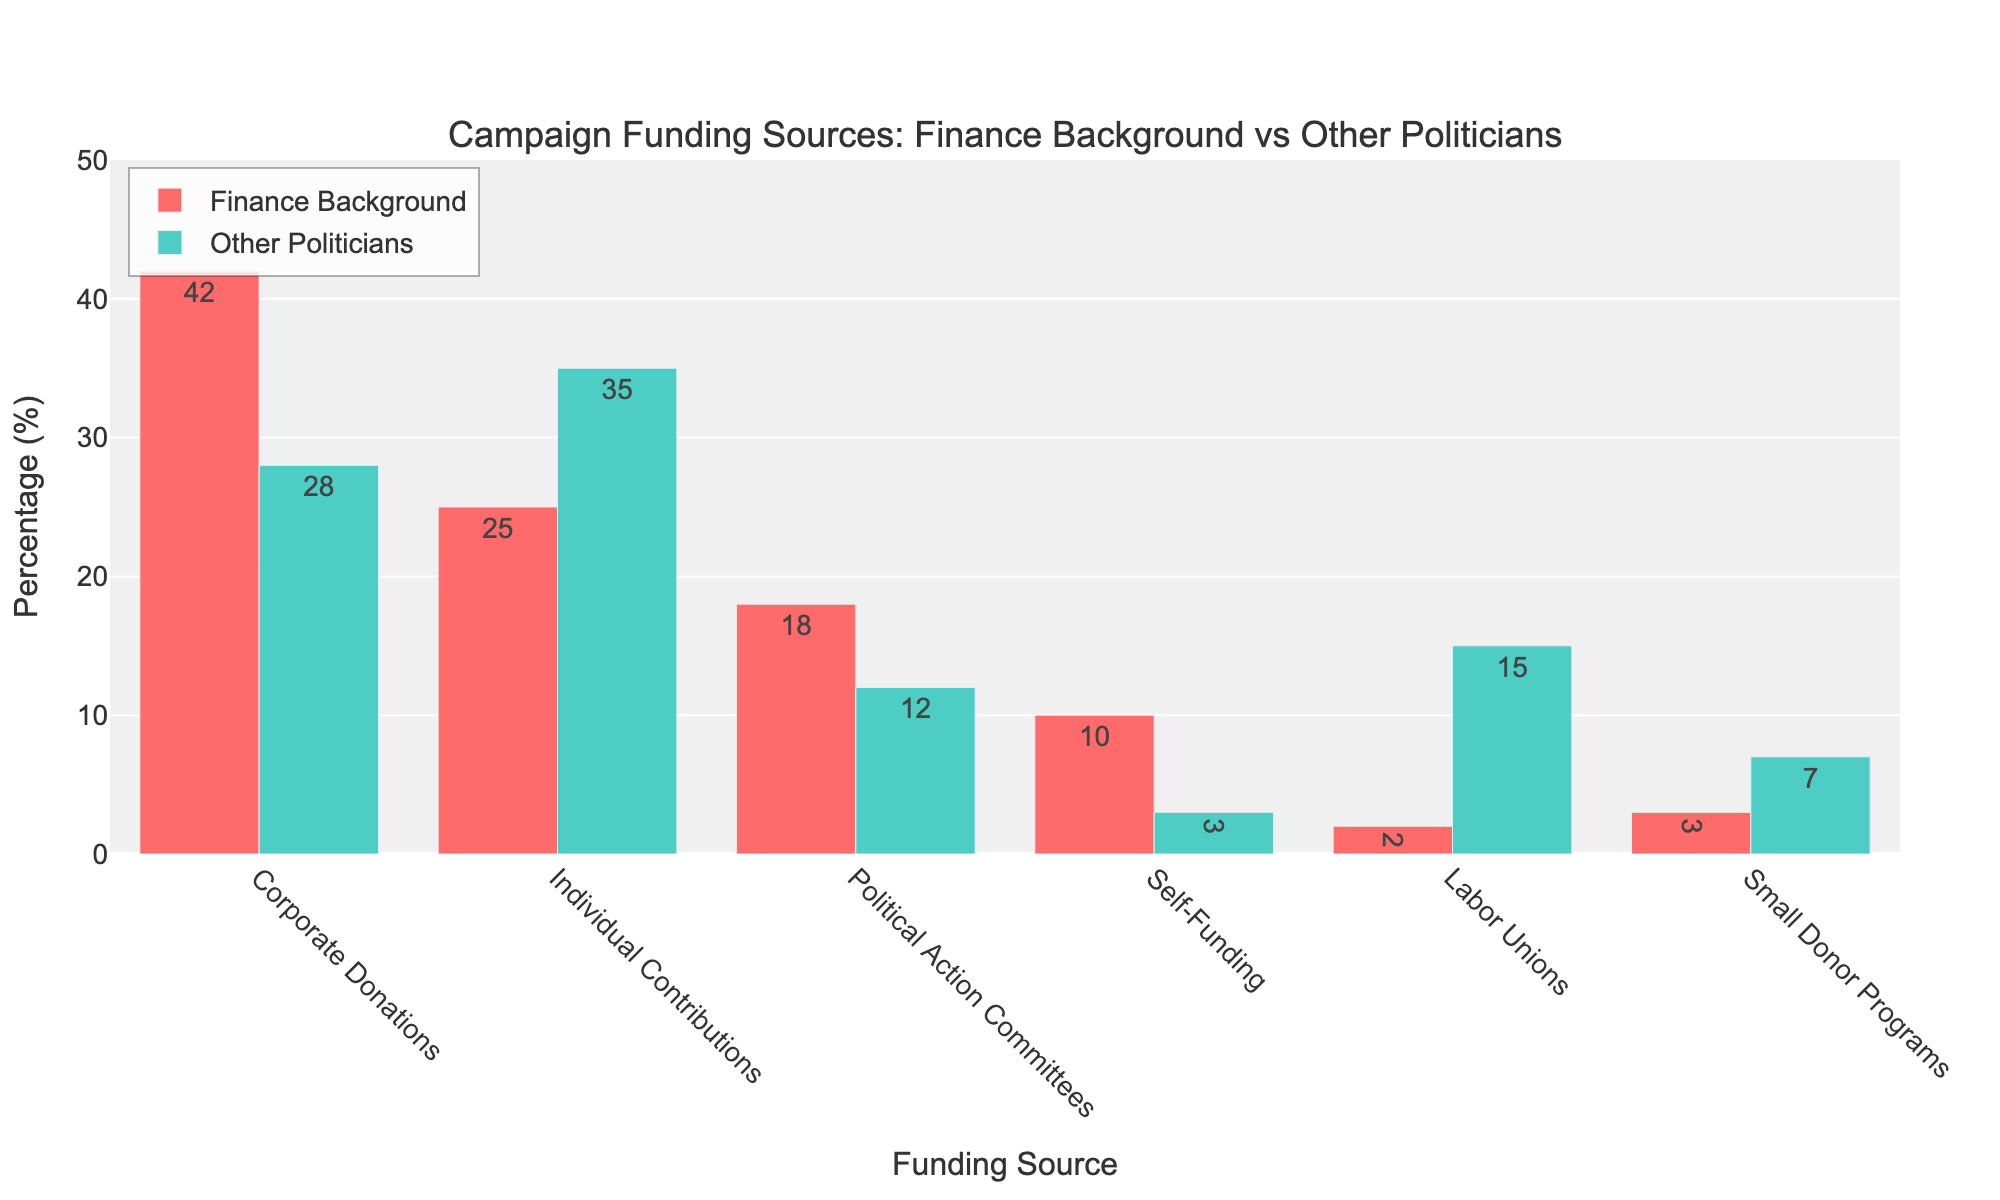What is the most significant source of campaign funding for politicians with a finance background? The tallest bar for politicians with a finance background is for "Corporate Donations," indicating it as the primary funding source.
Answer: Corporate Donations Which funding source shows the largest difference in percentage between politicians with a finance background and other politicians? By comparing the bars for each funding source, "Self-Funding" has a difference of 10 - 3 = 7%, which is the largest gap between the two groups.
Answer: Self-Funding Do labor unions contribute more to politicians with finance backgrounds or other politicians? The bar for "Labor Unions" under other politicians is taller than the corresponding bar for those with finance backgrounds (15% vs. 2%).
Answer: Other Politicians What is the combined percentage of campaign funding from individual contributions and political action committees for politicians with a finance background? Adding the percentages for individual contributions (25%) and political action committees (18%) gives 25 + 18 = 43%.
Answer: 43% Among small donor programs, how do the percentages compare for politicians with finance backgrounds versus other politicians? The bar for "Small Donor Programs" shows 3% for politicians with finance backgrounds and 7% for other politicians. Thus, others receive (7 - 3 = 4%) more funding from small donor programs.
Answer: Other Politicians receive 4% more Which funding source has the smallest percentage for politicians with a finance background? The shortest bar among all funding sources for finance-background politicians is "Labor Unions" at 2%.
Answer: Labor Unions What is the average percentage of campaign funding from corporate donations and self-funding for politicians with finance backgrounds? The average is calculated by adding the percentages for corporate donations (42%) and self-funding (10%) and then dividing by 2. Thus, (42 + 10) / 2 = 26%.
Answer: 26% How much higher is the percentage of corporate donations for politicians with finance backgrounds compared to other politicians? The bar for "Corporate Donations" is 42% for finance-background politicians and 28% for others. Thus, 42 - 28 = 14% higher.
Answer: 14% higher Which funding source has the highest percentage among other politicians? The tallest bar for other politicians is for "Individual Contributions," indicating it as the highest percentage source at 35%.
Answer: Individual Contributions How do the sources of campaign funding from political action committees compare between the two groups? The bar for "Political Action Committees" shows 18% for politicians with finance backgrounds and 12% for other politicians. Hence, finance-background politicians receive (18 - 12 = 6%) more funding from PACs.
Answer: Finance Background receive 6% more 